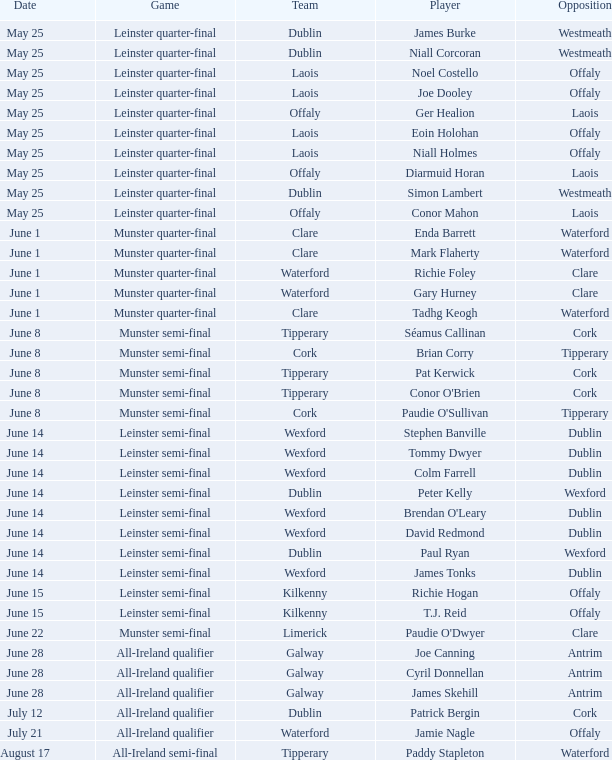What game did Eoin Holohan play in? Leinster quarter-final. 